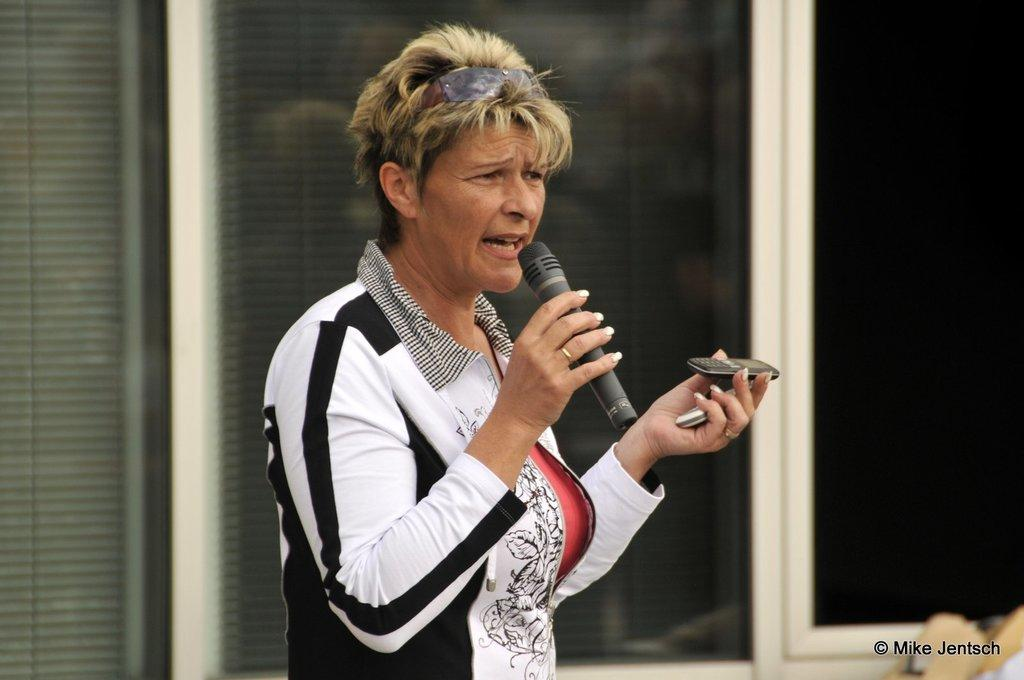Who is the main subject in the image? There is a woman in the image. What is the woman is wearing? The woman is wearing a black and white jacket. What is the woman holding in her hands? The woman is holding a microphone in one hand and a mobile phone in the other hand. What can be seen in the background of the image? There is a house in the background of the image. What type of calendar is hanging on the wall behind the woman in the image? There is no calendar present in the image; the background only shows a house. 